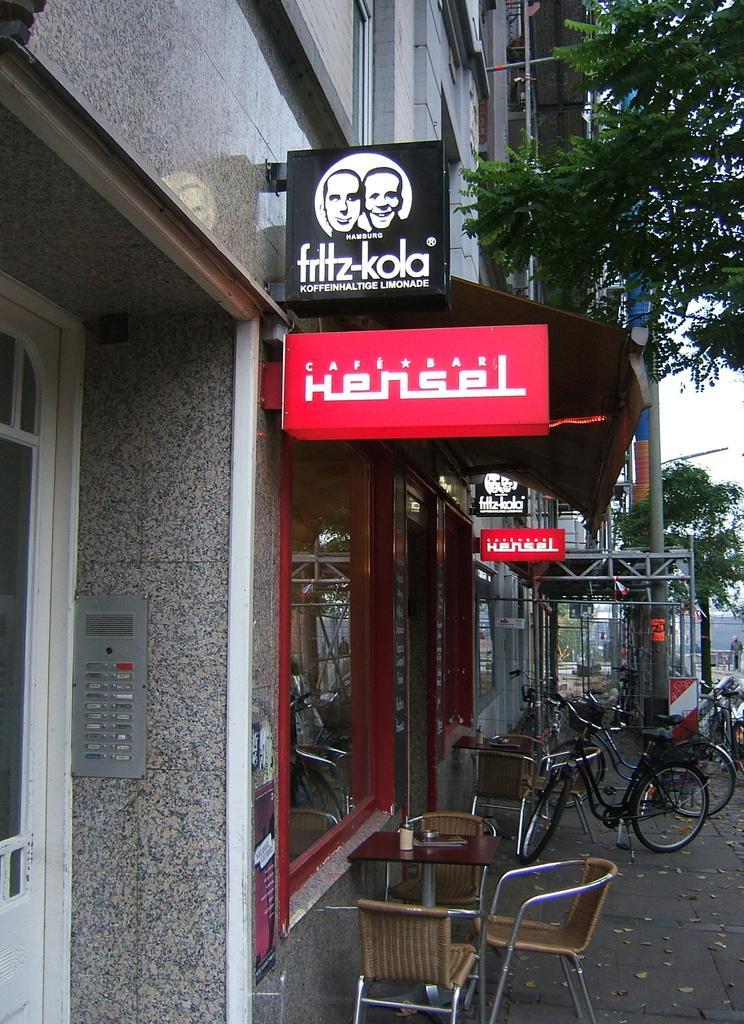In one or two sentences, can you explain what this image depicts? In this image there is a building , hoarding, name board , table , chair , bicycle , tree , sky , pole. 